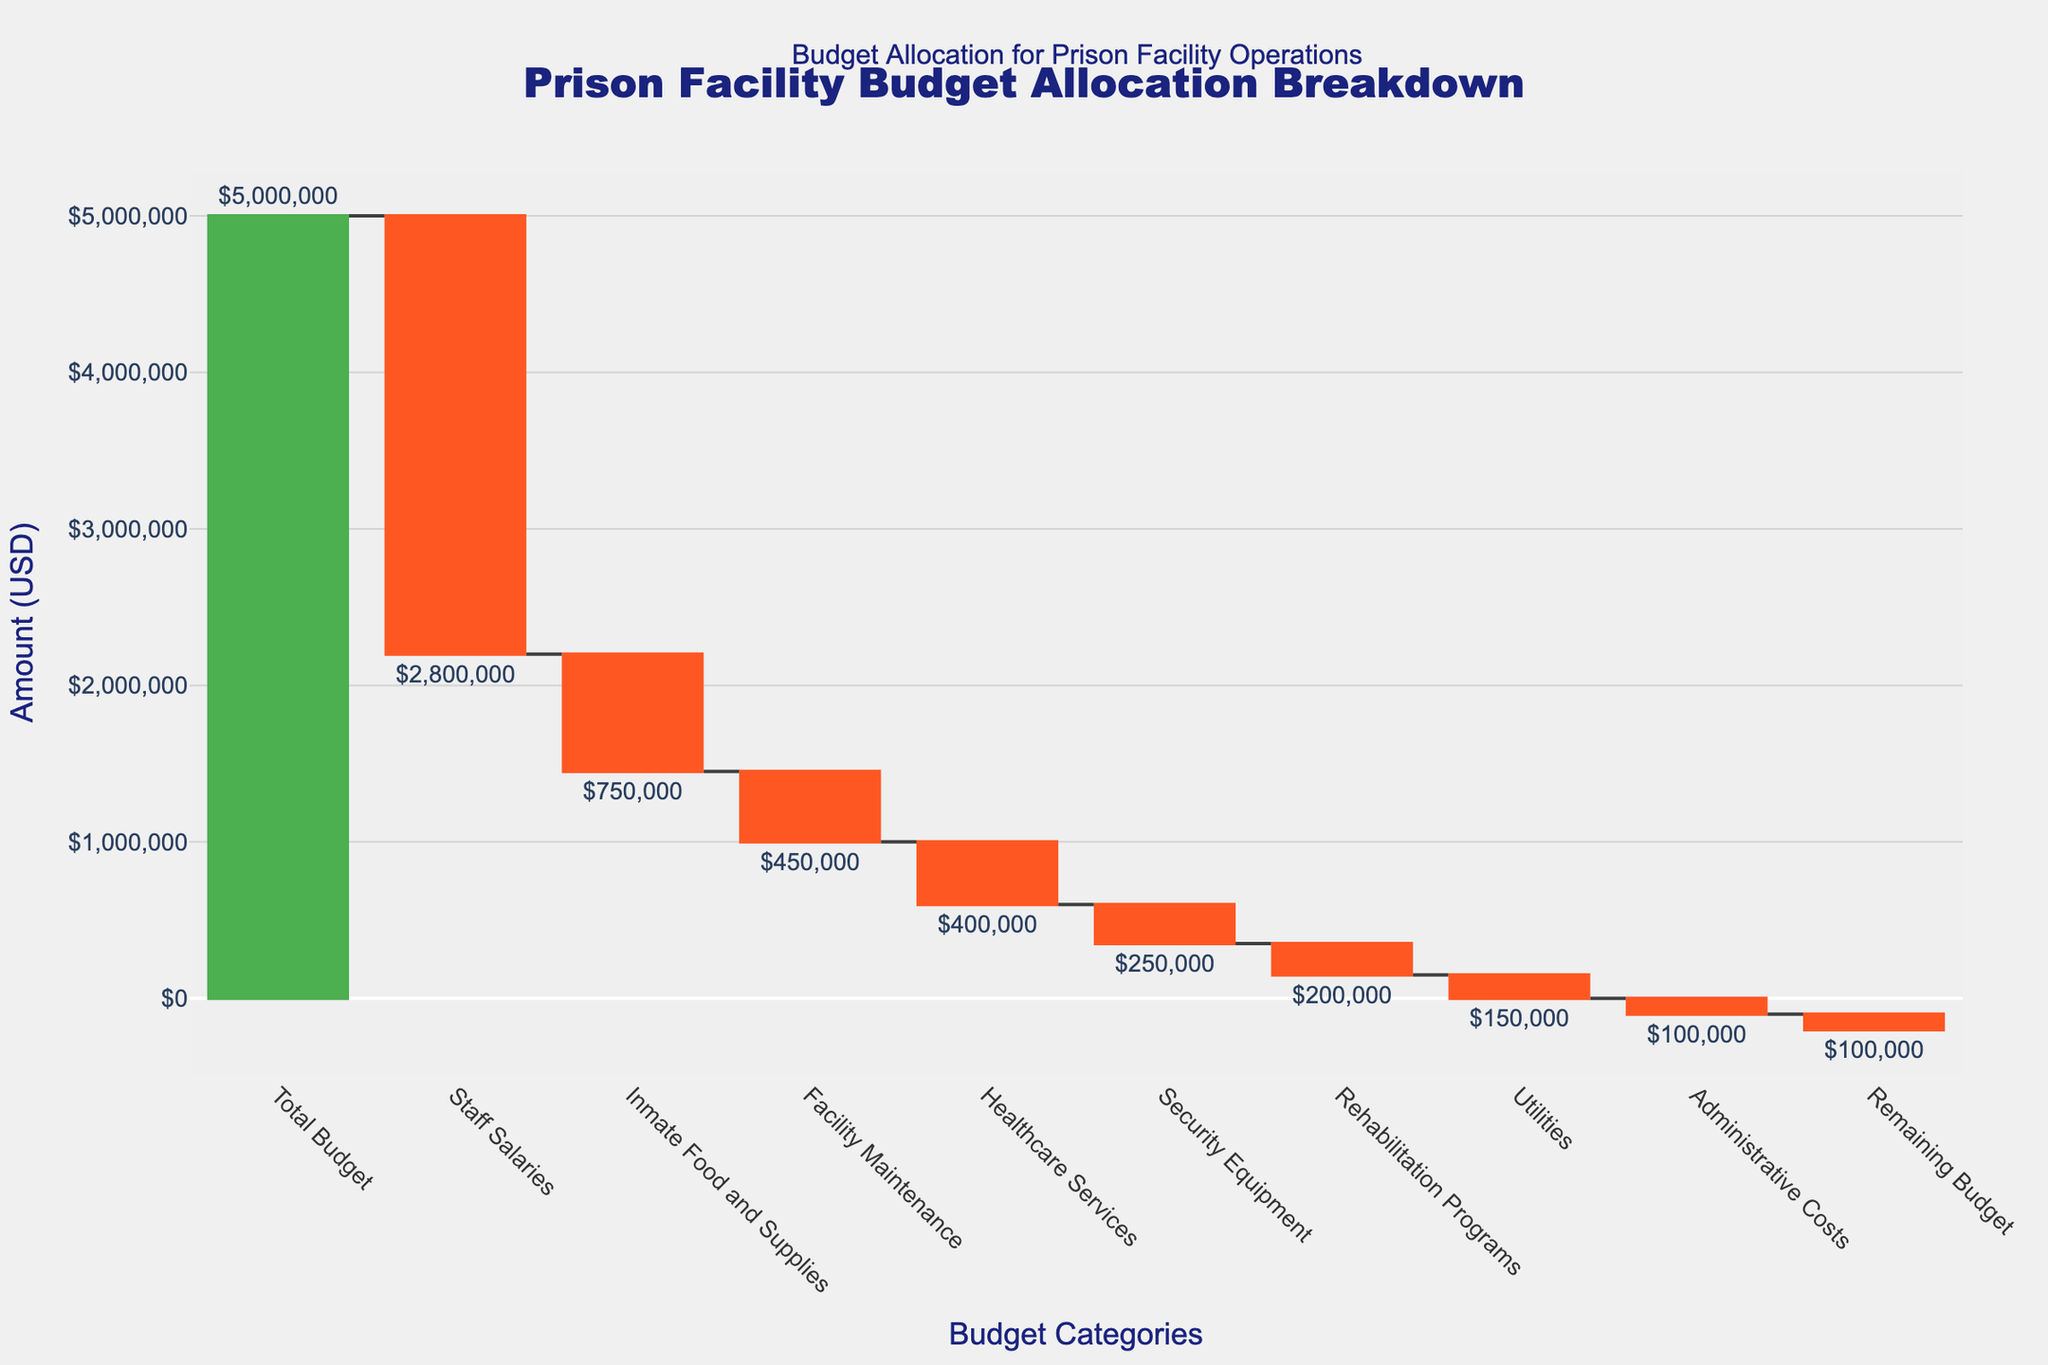What is the total budget allocated for the prison facility operations? The total budget is represented at the top of the waterfall chart. The "Total Budget" value is clearly labeled at the starting point.
Answer: $5,000,000 What category had the highest expenditure? To find the highest expenditure, look for the largest negative amount in the waterfall chart. The category labeled "Staff Salaries" has the maximum drop.
Answer: Staff Salaries How much is spent on inmate food and supplies? Locate the category "Inmate Food and Supplies" on the x-axis. The corresponding negative amount provided is the expenditure on this category.
Answer: $750,000 Which category has the smallest expenditure? Identify the smallest negative value among the categories. The smallest deduction is represented by "Administrative Costs."
Answer: Administrative Costs What percentage of the budget is spent on healthcare services? Divide the expenditure on "Healthcare Services" by the "Total Budget" and multiply by 100. ($400,000 / $5,000,000) * 100 = 8%
Answer: 8% How much budget remains after all expenditures? The remaining budget is located at the end of the waterfall chart, identified by "Remaining Budget."
Answer: $100,000 Which categories collectively make up more than half of the total budget? Add up each category's expenditure and check which combination exceeds half of the total budget. Staff Salaries ($2,800,000) alone is greater than half the total budget ($2,500,000). Hence, it makes up more than half.
Answer: Staff Salaries Compare the expenditures on security equipment and rehabilitation programs. Which one is higher? On the x-axis, compare the amounts for "Security Equipment" and "Rehabilitation Programs." The negative value for "Security Equipment" is greater than that for "Rehabilitation Programs."
Answer: Security Equipment What is the combined expenditure for facility maintenance and utilities? Sum the expenditures for "Facility Maintenance" and "Utilities." $450,000 + $150,000 = $600,000
Answer: $600,000 How do the expenditures on utilities and administrative costs compare to each other in percentage terms of the total budget? First, calculate the percentage of the total budget each category represents. Utilities: ($150,000 / $5,000,000) * 100 = 3%, Administrative Costs: ($100,000 / $5,000,000) * 100 = 2%.
Answer: Utilities: 3%, Administrative Costs: 2% 